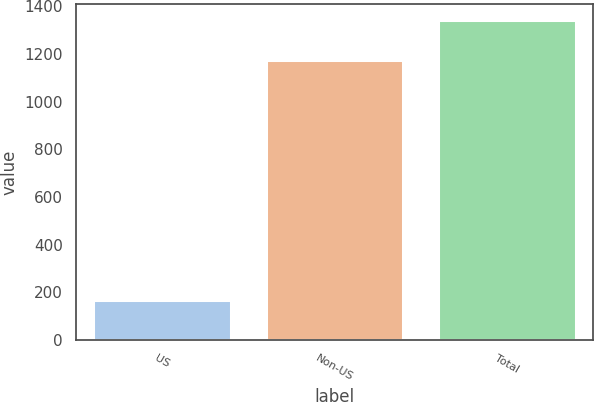Convert chart. <chart><loc_0><loc_0><loc_500><loc_500><bar_chart><fcel>US<fcel>Non-US<fcel>Total<nl><fcel>169<fcel>1175<fcel>1344<nl></chart> 